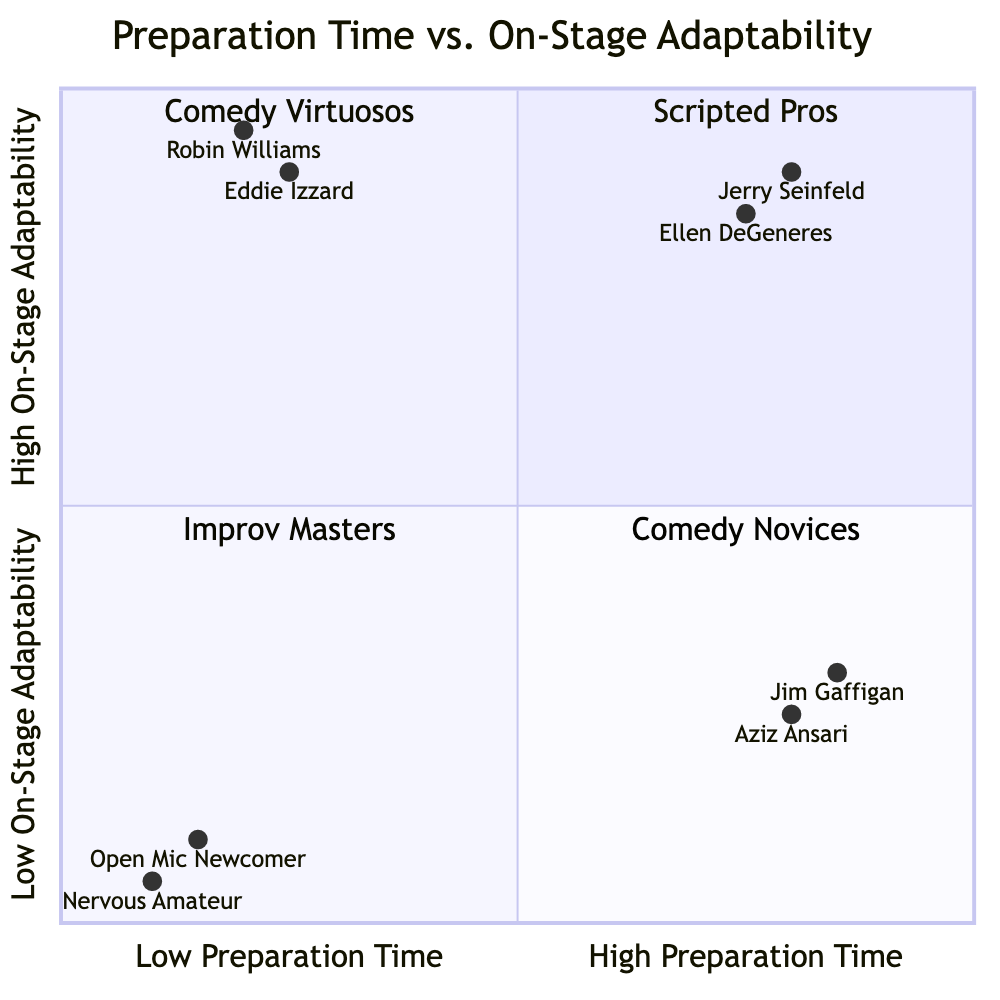What category does Jerry Seinfeld belong to? Jerry Seinfeld is located in the quadrant labeled "Scripted Pros" because he has high preparation time and high on-stage adaptability.
Answer: Scripted Pros How many comedians are in the "Comedy Novices" quadrant? The "Comedy Novices" quadrant contains two individuals: Open Mic Newcomer and Nervous Amateur.
Answer: 2 Which comedian shows the lowest adaptability on stage? The comedian with the lowest on-stage adaptability is Nervous Amateur, positioned in the "Comedy Novices" quadrant with a score of 0.05.
Answer: Nervous Amateur What is the y-coordinate of Eddie Izzard? Eddie Izzard's y-coordinate, representing his on-stage adaptability, is 0.9.
Answer: 0.9 How do Jim Gaffigan and Aziz Ansari compare in preparation time? Both Jim Gaffigan and Aziz Ansari have high preparation time, with Gaffigan having a score of 0.85 and Ansari a score of 0.8, but Gaffigan's adaptability is lower.
Answer: High preparation time Which quadrant has the comedian with the highest adaptability? The quadrant with the highest on-stage adaptability features Robin Williams and Eddie Izzard, who are both located in the "Improv Masters" quadrant.
Answer: Improv Masters What score does Open Mic Newcomer have in preparation time? Open Mic Newcomer has a preparation time score of 0.15, indicating low preparation time.
Answer: 0.15 Which comedian represents high on-stage adaptability with minimal preparation? Robin Williams represents high on-stage adaptability while having minimal preparation, as indicated by his position in the "Improv Masters" quadrant.
Answer: Robin Williams How does Ellen DeGeneres's preparedness compare to Jerry Seinfeld's? Ellen DeGeneres has a slightly lower preparation time score of 0.75 compared to Jerry Seinfeld's score of 0.8, though both are in the same quadrant.
Answer: Lower than Jerry Seinfeld 